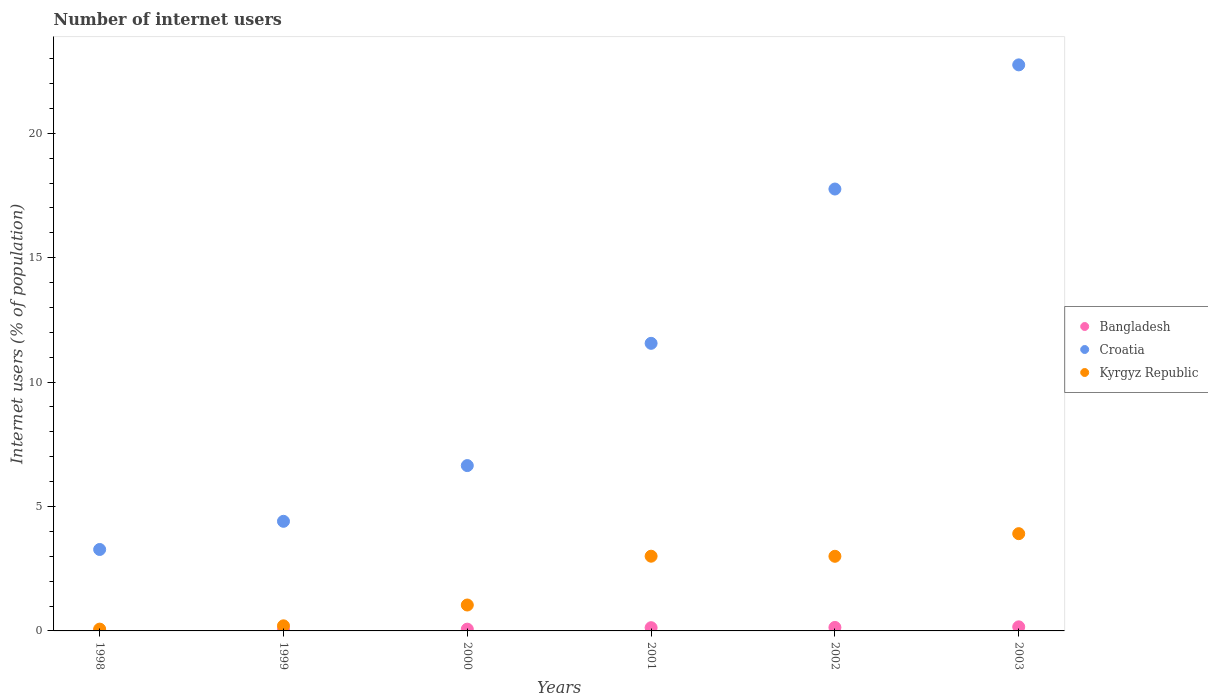Is the number of dotlines equal to the number of legend labels?
Your answer should be very brief. Yes. What is the number of internet users in Croatia in 2001?
Make the answer very short. 11.56. Across all years, what is the maximum number of internet users in Kyrgyz Republic?
Make the answer very short. 3.91. Across all years, what is the minimum number of internet users in Croatia?
Provide a short and direct response. 3.27. In which year was the number of internet users in Croatia maximum?
Offer a very short reply. 2003. What is the total number of internet users in Croatia in the graph?
Ensure brevity in your answer.  66.39. What is the difference between the number of internet users in Bangladesh in 1999 and that in 2000?
Offer a very short reply. -0.03. What is the difference between the number of internet users in Bangladesh in 1998 and the number of internet users in Kyrgyz Republic in 1999?
Ensure brevity in your answer.  -0.2. What is the average number of internet users in Croatia per year?
Make the answer very short. 11.07. In the year 1999, what is the difference between the number of internet users in Bangladesh and number of internet users in Kyrgyz Republic?
Give a very brief answer. -0.17. In how many years, is the number of internet users in Kyrgyz Republic greater than 12 %?
Keep it short and to the point. 0. What is the ratio of the number of internet users in Kyrgyz Republic in 1999 to that in 2000?
Your answer should be compact. 0.2. Is the number of internet users in Croatia in 1999 less than that in 2001?
Offer a very short reply. Yes. What is the difference between the highest and the second highest number of internet users in Kyrgyz Republic?
Your answer should be compact. 0.91. What is the difference between the highest and the lowest number of internet users in Croatia?
Your response must be concise. 19.48. Is the number of internet users in Croatia strictly greater than the number of internet users in Kyrgyz Republic over the years?
Offer a very short reply. Yes. Is the number of internet users in Bangladesh strictly less than the number of internet users in Croatia over the years?
Provide a succinct answer. Yes. How many years are there in the graph?
Your response must be concise. 6. What is the difference between two consecutive major ticks on the Y-axis?
Give a very brief answer. 5. Are the values on the major ticks of Y-axis written in scientific E-notation?
Your answer should be compact. No. How many legend labels are there?
Your answer should be compact. 3. What is the title of the graph?
Provide a succinct answer. Number of internet users. What is the label or title of the Y-axis?
Provide a succinct answer. Internet users (% of population). What is the Internet users (% of population) in Bangladesh in 1998?
Offer a very short reply. 0. What is the Internet users (% of population) in Croatia in 1998?
Provide a short and direct response. 3.27. What is the Internet users (% of population) in Kyrgyz Republic in 1998?
Keep it short and to the point. 0.07. What is the Internet users (% of population) in Bangladesh in 1999?
Your response must be concise. 0.04. What is the Internet users (% of population) of Croatia in 1999?
Your answer should be very brief. 4.41. What is the Internet users (% of population) in Kyrgyz Republic in 1999?
Offer a terse response. 0.2. What is the Internet users (% of population) in Bangladesh in 2000?
Give a very brief answer. 0.07. What is the Internet users (% of population) in Croatia in 2000?
Ensure brevity in your answer.  6.64. What is the Internet users (% of population) in Kyrgyz Republic in 2000?
Offer a very short reply. 1.04. What is the Internet users (% of population) of Bangladesh in 2001?
Offer a very short reply. 0.13. What is the Internet users (% of population) in Croatia in 2001?
Provide a short and direct response. 11.56. What is the Internet users (% of population) in Kyrgyz Republic in 2001?
Offer a terse response. 3. What is the Internet users (% of population) in Bangladesh in 2002?
Your answer should be very brief. 0.14. What is the Internet users (% of population) in Croatia in 2002?
Ensure brevity in your answer.  17.76. What is the Internet users (% of population) of Kyrgyz Republic in 2002?
Ensure brevity in your answer.  3. What is the Internet users (% of population) of Bangladesh in 2003?
Your answer should be compact. 0.16. What is the Internet users (% of population) of Croatia in 2003?
Make the answer very short. 22.75. What is the Internet users (% of population) in Kyrgyz Republic in 2003?
Give a very brief answer. 3.91. Across all years, what is the maximum Internet users (% of population) in Bangladesh?
Provide a short and direct response. 0.16. Across all years, what is the maximum Internet users (% of population) of Croatia?
Keep it short and to the point. 22.75. Across all years, what is the maximum Internet users (% of population) in Kyrgyz Republic?
Your answer should be very brief. 3.91. Across all years, what is the minimum Internet users (% of population) in Bangladesh?
Keep it short and to the point. 0. Across all years, what is the minimum Internet users (% of population) of Croatia?
Provide a short and direct response. 3.27. Across all years, what is the minimum Internet users (% of population) of Kyrgyz Republic?
Make the answer very short. 0.07. What is the total Internet users (% of population) in Bangladesh in the graph?
Your answer should be very brief. 0.54. What is the total Internet users (% of population) in Croatia in the graph?
Give a very brief answer. 66.39. What is the total Internet users (% of population) in Kyrgyz Republic in the graph?
Offer a very short reply. 11.23. What is the difference between the Internet users (% of population) of Bangladesh in 1998 and that in 1999?
Offer a very short reply. -0.03. What is the difference between the Internet users (% of population) of Croatia in 1998 and that in 1999?
Provide a succinct answer. -1.13. What is the difference between the Internet users (% of population) in Kyrgyz Republic in 1998 and that in 1999?
Your response must be concise. -0.13. What is the difference between the Internet users (% of population) in Bangladesh in 1998 and that in 2000?
Give a very brief answer. -0.07. What is the difference between the Internet users (% of population) in Croatia in 1998 and that in 2000?
Your response must be concise. -3.37. What is the difference between the Internet users (% of population) in Kyrgyz Republic in 1998 and that in 2000?
Ensure brevity in your answer.  -0.97. What is the difference between the Internet users (% of population) of Bangladesh in 1998 and that in 2001?
Provide a short and direct response. -0.13. What is the difference between the Internet users (% of population) in Croatia in 1998 and that in 2001?
Provide a short and direct response. -8.29. What is the difference between the Internet users (% of population) in Kyrgyz Republic in 1998 and that in 2001?
Make the answer very short. -2.93. What is the difference between the Internet users (% of population) of Bangladesh in 1998 and that in 2002?
Ensure brevity in your answer.  -0.14. What is the difference between the Internet users (% of population) of Croatia in 1998 and that in 2002?
Give a very brief answer. -14.49. What is the difference between the Internet users (% of population) of Kyrgyz Republic in 1998 and that in 2002?
Offer a terse response. -2.93. What is the difference between the Internet users (% of population) in Bangladesh in 1998 and that in 2003?
Make the answer very short. -0.16. What is the difference between the Internet users (% of population) in Croatia in 1998 and that in 2003?
Offer a terse response. -19.48. What is the difference between the Internet users (% of population) of Kyrgyz Republic in 1998 and that in 2003?
Ensure brevity in your answer.  -3.84. What is the difference between the Internet users (% of population) of Bangladesh in 1999 and that in 2000?
Your response must be concise. -0.03. What is the difference between the Internet users (% of population) in Croatia in 1999 and that in 2000?
Make the answer very short. -2.24. What is the difference between the Internet users (% of population) of Kyrgyz Republic in 1999 and that in 2000?
Offer a terse response. -0.84. What is the difference between the Internet users (% of population) of Bangladesh in 1999 and that in 2001?
Ensure brevity in your answer.  -0.09. What is the difference between the Internet users (% of population) in Croatia in 1999 and that in 2001?
Ensure brevity in your answer.  -7.15. What is the difference between the Internet users (% of population) in Kyrgyz Republic in 1999 and that in 2001?
Provide a succinct answer. -2.8. What is the difference between the Internet users (% of population) in Bangladesh in 1999 and that in 2002?
Offer a terse response. -0.1. What is the difference between the Internet users (% of population) in Croatia in 1999 and that in 2002?
Make the answer very short. -13.35. What is the difference between the Internet users (% of population) in Kyrgyz Republic in 1999 and that in 2002?
Your answer should be compact. -2.79. What is the difference between the Internet users (% of population) of Bangladesh in 1999 and that in 2003?
Provide a succinct answer. -0.13. What is the difference between the Internet users (% of population) of Croatia in 1999 and that in 2003?
Make the answer very short. -18.34. What is the difference between the Internet users (% of population) in Kyrgyz Republic in 1999 and that in 2003?
Ensure brevity in your answer.  -3.7. What is the difference between the Internet users (% of population) in Bangladesh in 2000 and that in 2001?
Give a very brief answer. -0.06. What is the difference between the Internet users (% of population) of Croatia in 2000 and that in 2001?
Your answer should be compact. -4.91. What is the difference between the Internet users (% of population) in Kyrgyz Republic in 2000 and that in 2001?
Ensure brevity in your answer.  -1.96. What is the difference between the Internet users (% of population) in Bangladesh in 2000 and that in 2002?
Ensure brevity in your answer.  -0.07. What is the difference between the Internet users (% of population) of Croatia in 2000 and that in 2002?
Give a very brief answer. -11.12. What is the difference between the Internet users (% of population) in Kyrgyz Republic in 2000 and that in 2002?
Offer a terse response. -1.96. What is the difference between the Internet users (% of population) in Bangladesh in 2000 and that in 2003?
Your answer should be compact. -0.09. What is the difference between the Internet users (% of population) of Croatia in 2000 and that in 2003?
Offer a very short reply. -16.11. What is the difference between the Internet users (% of population) of Kyrgyz Republic in 2000 and that in 2003?
Offer a terse response. -2.87. What is the difference between the Internet users (% of population) of Bangladesh in 2001 and that in 2002?
Offer a terse response. -0.01. What is the difference between the Internet users (% of population) of Croatia in 2001 and that in 2002?
Make the answer very short. -6.2. What is the difference between the Internet users (% of population) of Kyrgyz Republic in 2001 and that in 2002?
Your answer should be compact. 0. What is the difference between the Internet users (% of population) in Bangladesh in 2001 and that in 2003?
Your answer should be very brief. -0.03. What is the difference between the Internet users (% of population) in Croatia in 2001 and that in 2003?
Give a very brief answer. -11.19. What is the difference between the Internet users (% of population) in Kyrgyz Republic in 2001 and that in 2003?
Your answer should be very brief. -0.91. What is the difference between the Internet users (% of population) of Bangladesh in 2002 and that in 2003?
Ensure brevity in your answer.  -0.02. What is the difference between the Internet users (% of population) of Croatia in 2002 and that in 2003?
Provide a succinct answer. -4.99. What is the difference between the Internet users (% of population) in Kyrgyz Republic in 2002 and that in 2003?
Offer a terse response. -0.91. What is the difference between the Internet users (% of population) in Bangladesh in 1998 and the Internet users (% of population) in Croatia in 1999?
Provide a short and direct response. -4.4. What is the difference between the Internet users (% of population) of Bangladesh in 1998 and the Internet users (% of population) of Kyrgyz Republic in 1999?
Provide a short and direct response. -0.2. What is the difference between the Internet users (% of population) of Croatia in 1998 and the Internet users (% of population) of Kyrgyz Republic in 1999?
Your response must be concise. 3.07. What is the difference between the Internet users (% of population) in Bangladesh in 1998 and the Internet users (% of population) in Croatia in 2000?
Offer a very short reply. -6.64. What is the difference between the Internet users (% of population) of Bangladesh in 1998 and the Internet users (% of population) of Kyrgyz Republic in 2000?
Offer a terse response. -1.04. What is the difference between the Internet users (% of population) in Croatia in 1998 and the Internet users (% of population) in Kyrgyz Republic in 2000?
Keep it short and to the point. 2.23. What is the difference between the Internet users (% of population) in Bangladesh in 1998 and the Internet users (% of population) in Croatia in 2001?
Give a very brief answer. -11.55. What is the difference between the Internet users (% of population) of Bangladesh in 1998 and the Internet users (% of population) of Kyrgyz Republic in 2001?
Your answer should be very brief. -3. What is the difference between the Internet users (% of population) of Croatia in 1998 and the Internet users (% of population) of Kyrgyz Republic in 2001?
Keep it short and to the point. 0.27. What is the difference between the Internet users (% of population) in Bangladesh in 1998 and the Internet users (% of population) in Croatia in 2002?
Make the answer very short. -17.76. What is the difference between the Internet users (% of population) of Bangladesh in 1998 and the Internet users (% of population) of Kyrgyz Republic in 2002?
Your response must be concise. -3. What is the difference between the Internet users (% of population) in Croatia in 1998 and the Internet users (% of population) in Kyrgyz Republic in 2002?
Provide a succinct answer. 0.27. What is the difference between the Internet users (% of population) of Bangladesh in 1998 and the Internet users (% of population) of Croatia in 2003?
Provide a succinct answer. -22.75. What is the difference between the Internet users (% of population) in Bangladesh in 1998 and the Internet users (% of population) in Kyrgyz Republic in 2003?
Your response must be concise. -3.91. What is the difference between the Internet users (% of population) of Croatia in 1998 and the Internet users (% of population) of Kyrgyz Republic in 2003?
Offer a very short reply. -0.64. What is the difference between the Internet users (% of population) of Bangladesh in 1999 and the Internet users (% of population) of Croatia in 2000?
Give a very brief answer. -6.61. What is the difference between the Internet users (% of population) of Bangladesh in 1999 and the Internet users (% of population) of Kyrgyz Republic in 2000?
Offer a terse response. -1.01. What is the difference between the Internet users (% of population) of Croatia in 1999 and the Internet users (% of population) of Kyrgyz Republic in 2000?
Offer a terse response. 3.36. What is the difference between the Internet users (% of population) in Bangladesh in 1999 and the Internet users (% of population) in Croatia in 2001?
Your answer should be compact. -11.52. What is the difference between the Internet users (% of population) of Bangladesh in 1999 and the Internet users (% of population) of Kyrgyz Republic in 2001?
Offer a terse response. -2.97. What is the difference between the Internet users (% of population) of Croatia in 1999 and the Internet users (% of population) of Kyrgyz Republic in 2001?
Provide a succinct answer. 1.4. What is the difference between the Internet users (% of population) of Bangladesh in 1999 and the Internet users (% of population) of Croatia in 2002?
Offer a very short reply. -17.72. What is the difference between the Internet users (% of population) of Bangladesh in 1999 and the Internet users (% of population) of Kyrgyz Republic in 2002?
Your answer should be very brief. -2.96. What is the difference between the Internet users (% of population) in Croatia in 1999 and the Internet users (% of population) in Kyrgyz Republic in 2002?
Your response must be concise. 1.41. What is the difference between the Internet users (% of population) of Bangladesh in 1999 and the Internet users (% of population) of Croatia in 2003?
Keep it short and to the point. -22.71. What is the difference between the Internet users (% of population) of Bangladesh in 1999 and the Internet users (% of population) of Kyrgyz Republic in 2003?
Your answer should be very brief. -3.87. What is the difference between the Internet users (% of population) in Croatia in 1999 and the Internet users (% of population) in Kyrgyz Republic in 2003?
Provide a short and direct response. 0.5. What is the difference between the Internet users (% of population) of Bangladesh in 2000 and the Internet users (% of population) of Croatia in 2001?
Offer a terse response. -11.49. What is the difference between the Internet users (% of population) in Bangladesh in 2000 and the Internet users (% of population) in Kyrgyz Republic in 2001?
Your answer should be very brief. -2.93. What is the difference between the Internet users (% of population) in Croatia in 2000 and the Internet users (% of population) in Kyrgyz Republic in 2001?
Keep it short and to the point. 3.64. What is the difference between the Internet users (% of population) in Bangladesh in 2000 and the Internet users (% of population) in Croatia in 2002?
Make the answer very short. -17.69. What is the difference between the Internet users (% of population) of Bangladesh in 2000 and the Internet users (% of population) of Kyrgyz Republic in 2002?
Give a very brief answer. -2.93. What is the difference between the Internet users (% of population) of Croatia in 2000 and the Internet users (% of population) of Kyrgyz Republic in 2002?
Provide a succinct answer. 3.65. What is the difference between the Internet users (% of population) in Bangladesh in 2000 and the Internet users (% of population) in Croatia in 2003?
Offer a very short reply. -22.68. What is the difference between the Internet users (% of population) in Bangladesh in 2000 and the Internet users (% of population) in Kyrgyz Republic in 2003?
Offer a very short reply. -3.84. What is the difference between the Internet users (% of population) in Croatia in 2000 and the Internet users (% of population) in Kyrgyz Republic in 2003?
Give a very brief answer. 2.74. What is the difference between the Internet users (% of population) in Bangladesh in 2001 and the Internet users (% of population) in Croatia in 2002?
Provide a short and direct response. -17.63. What is the difference between the Internet users (% of population) of Bangladesh in 2001 and the Internet users (% of population) of Kyrgyz Republic in 2002?
Provide a short and direct response. -2.87. What is the difference between the Internet users (% of population) in Croatia in 2001 and the Internet users (% of population) in Kyrgyz Republic in 2002?
Offer a very short reply. 8.56. What is the difference between the Internet users (% of population) of Bangladesh in 2001 and the Internet users (% of population) of Croatia in 2003?
Your answer should be very brief. -22.62. What is the difference between the Internet users (% of population) in Bangladesh in 2001 and the Internet users (% of population) in Kyrgyz Republic in 2003?
Your response must be concise. -3.78. What is the difference between the Internet users (% of population) in Croatia in 2001 and the Internet users (% of population) in Kyrgyz Republic in 2003?
Your response must be concise. 7.65. What is the difference between the Internet users (% of population) of Bangladesh in 2002 and the Internet users (% of population) of Croatia in 2003?
Keep it short and to the point. -22.61. What is the difference between the Internet users (% of population) of Bangladesh in 2002 and the Internet users (% of population) of Kyrgyz Republic in 2003?
Your response must be concise. -3.77. What is the difference between the Internet users (% of population) in Croatia in 2002 and the Internet users (% of population) in Kyrgyz Republic in 2003?
Your answer should be compact. 13.85. What is the average Internet users (% of population) in Bangladesh per year?
Make the answer very short. 0.09. What is the average Internet users (% of population) of Croatia per year?
Provide a short and direct response. 11.07. What is the average Internet users (% of population) in Kyrgyz Republic per year?
Your response must be concise. 1.87. In the year 1998, what is the difference between the Internet users (% of population) in Bangladesh and Internet users (% of population) in Croatia?
Offer a terse response. -3.27. In the year 1998, what is the difference between the Internet users (% of population) in Bangladesh and Internet users (% of population) in Kyrgyz Republic?
Offer a terse response. -0.07. In the year 1998, what is the difference between the Internet users (% of population) in Croatia and Internet users (% of population) in Kyrgyz Republic?
Your answer should be very brief. 3.2. In the year 1999, what is the difference between the Internet users (% of population) of Bangladesh and Internet users (% of population) of Croatia?
Make the answer very short. -4.37. In the year 1999, what is the difference between the Internet users (% of population) of Bangladesh and Internet users (% of population) of Kyrgyz Republic?
Your answer should be compact. -0.17. In the year 1999, what is the difference between the Internet users (% of population) of Croatia and Internet users (% of population) of Kyrgyz Republic?
Provide a succinct answer. 4.2. In the year 2000, what is the difference between the Internet users (% of population) in Bangladesh and Internet users (% of population) in Croatia?
Provide a succinct answer. -6.57. In the year 2000, what is the difference between the Internet users (% of population) in Bangladesh and Internet users (% of population) in Kyrgyz Republic?
Your response must be concise. -0.97. In the year 2000, what is the difference between the Internet users (% of population) in Croatia and Internet users (% of population) in Kyrgyz Republic?
Offer a very short reply. 5.6. In the year 2001, what is the difference between the Internet users (% of population) in Bangladesh and Internet users (% of population) in Croatia?
Give a very brief answer. -11.43. In the year 2001, what is the difference between the Internet users (% of population) of Bangladesh and Internet users (% of population) of Kyrgyz Republic?
Provide a short and direct response. -2.87. In the year 2001, what is the difference between the Internet users (% of population) in Croatia and Internet users (% of population) in Kyrgyz Republic?
Your answer should be very brief. 8.56. In the year 2002, what is the difference between the Internet users (% of population) of Bangladesh and Internet users (% of population) of Croatia?
Provide a short and direct response. -17.62. In the year 2002, what is the difference between the Internet users (% of population) of Bangladesh and Internet users (% of population) of Kyrgyz Republic?
Your answer should be compact. -2.86. In the year 2002, what is the difference between the Internet users (% of population) of Croatia and Internet users (% of population) of Kyrgyz Republic?
Provide a short and direct response. 14.76. In the year 2003, what is the difference between the Internet users (% of population) in Bangladesh and Internet users (% of population) in Croatia?
Ensure brevity in your answer.  -22.59. In the year 2003, what is the difference between the Internet users (% of population) in Bangladesh and Internet users (% of population) in Kyrgyz Republic?
Provide a succinct answer. -3.74. In the year 2003, what is the difference between the Internet users (% of population) in Croatia and Internet users (% of population) in Kyrgyz Republic?
Provide a succinct answer. 18.84. What is the ratio of the Internet users (% of population) in Bangladesh in 1998 to that in 1999?
Give a very brief answer. 0.1. What is the ratio of the Internet users (% of population) of Croatia in 1998 to that in 1999?
Your answer should be compact. 0.74. What is the ratio of the Internet users (% of population) in Kyrgyz Republic in 1998 to that in 1999?
Offer a terse response. 0.36. What is the ratio of the Internet users (% of population) of Bangladesh in 1998 to that in 2000?
Your response must be concise. 0.05. What is the ratio of the Internet users (% of population) in Croatia in 1998 to that in 2000?
Keep it short and to the point. 0.49. What is the ratio of the Internet users (% of population) of Kyrgyz Republic in 1998 to that in 2000?
Give a very brief answer. 0.07. What is the ratio of the Internet users (% of population) of Bangladesh in 1998 to that in 2001?
Offer a terse response. 0.03. What is the ratio of the Internet users (% of population) in Croatia in 1998 to that in 2001?
Offer a terse response. 0.28. What is the ratio of the Internet users (% of population) in Kyrgyz Republic in 1998 to that in 2001?
Ensure brevity in your answer.  0.02. What is the ratio of the Internet users (% of population) in Bangladesh in 1998 to that in 2002?
Make the answer very short. 0.03. What is the ratio of the Internet users (% of population) of Croatia in 1998 to that in 2002?
Give a very brief answer. 0.18. What is the ratio of the Internet users (% of population) of Kyrgyz Republic in 1998 to that in 2002?
Give a very brief answer. 0.02. What is the ratio of the Internet users (% of population) of Bangladesh in 1998 to that in 2003?
Your answer should be compact. 0.02. What is the ratio of the Internet users (% of population) in Croatia in 1998 to that in 2003?
Offer a terse response. 0.14. What is the ratio of the Internet users (% of population) of Kyrgyz Republic in 1998 to that in 2003?
Your answer should be very brief. 0.02. What is the ratio of the Internet users (% of population) of Bangladesh in 1999 to that in 2000?
Provide a short and direct response. 0.51. What is the ratio of the Internet users (% of population) of Croatia in 1999 to that in 2000?
Provide a short and direct response. 0.66. What is the ratio of the Internet users (% of population) in Kyrgyz Republic in 1999 to that in 2000?
Give a very brief answer. 0.2. What is the ratio of the Internet users (% of population) in Bangladesh in 1999 to that in 2001?
Provide a succinct answer. 0.28. What is the ratio of the Internet users (% of population) of Croatia in 1999 to that in 2001?
Keep it short and to the point. 0.38. What is the ratio of the Internet users (% of population) of Kyrgyz Republic in 1999 to that in 2001?
Your answer should be compact. 0.07. What is the ratio of the Internet users (% of population) of Bangladesh in 1999 to that in 2002?
Your answer should be compact. 0.26. What is the ratio of the Internet users (% of population) of Croatia in 1999 to that in 2002?
Your response must be concise. 0.25. What is the ratio of the Internet users (% of population) in Kyrgyz Republic in 1999 to that in 2002?
Make the answer very short. 0.07. What is the ratio of the Internet users (% of population) of Bangladesh in 1999 to that in 2003?
Give a very brief answer. 0.22. What is the ratio of the Internet users (% of population) of Croatia in 1999 to that in 2003?
Keep it short and to the point. 0.19. What is the ratio of the Internet users (% of population) in Kyrgyz Republic in 1999 to that in 2003?
Your response must be concise. 0.05. What is the ratio of the Internet users (% of population) in Bangladesh in 2000 to that in 2001?
Your response must be concise. 0.55. What is the ratio of the Internet users (% of population) of Croatia in 2000 to that in 2001?
Offer a terse response. 0.57. What is the ratio of the Internet users (% of population) in Kyrgyz Republic in 2000 to that in 2001?
Offer a terse response. 0.35. What is the ratio of the Internet users (% of population) of Bangladesh in 2000 to that in 2002?
Provide a short and direct response. 0.51. What is the ratio of the Internet users (% of population) in Croatia in 2000 to that in 2002?
Your response must be concise. 0.37. What is the ratio of the Internet users (% of population) in Kyrgyz Republic in 2000 to that in 2002?
Your answer should be compact. 0.35. What is the ratio of the Internet users (% of population) in Bangladesh in 2000 to that in 2003?
Your answer should be compact. 0.43. What is the ratio of the Internet users (% of population) in Croatia in 2000 to that in 2003?
Provide a short and direct response. 0.29. What is the ratio of the Internet users (% of population) of Kyrgyz Republic in 2000 to that in 2003?
Keep it short and to the point. 0.27. What is the ratio of the Internet users (% of population) of Bangladesh in 2001 to that in 2002?
Provide a short and direct response. 0.93. What is the ratio of the Internet users (% of population) of Croatia in 2001 to that in 2002?
Offer a terse response. 0.65. What is the ratio of the Internet users (% of population) in Bangladesh in 2001 to that in 2003?
Make the answer very short. 0.79. What is the ratio of the Internet users (% of population) in Croatia in 2001 to that in 2003?
Your answer should be very brief. 0.51. What is the ratio of the Internet users (% of population) of Kyrgyz Republic in 2001 to that in 2003?
Offer a terse response. 0.77. What is the ratio of the Internet users (% of population) in Bangladesh in 2002 to that in 2003?
Provide a succinct answer. 0.85. What is the ratio of the Internet users (% of population) of Croatia in 2002 to that in 2003?
Keep it short and to the point. 0.78. What is the ratio of the Internet users (% of population) in Kyrgyz Republic in 2002 to that in 2003?
Provide a succinct answer. 0.77. What is the difference between the highest and the second highest Internet users (% of population) of Bangladesh?
Ensure brevity in your answer.  0.02. What is the difference between the highest and the second highest Internet users (% of population) in Croatia?
Your answer should be very brief. 4.99. What is the difference between the highest and the second highest Internet users (% of population) in Kyrgyz Republic?
Offer a very short reply. 0.91. What is the difference between the highest and the lowest Internet users (% of population) of Bangladesh?
Provide a succinct answer. 0.16. What is the difference between the highest and the lowest Internet users (% of population) in Croatia?
Your answer should be compact. 19.48. What is the difference between the highest and the lowest Internet users (% of population) of Kyrgyz Republic?
Provide a short and direct response. 3.84. 